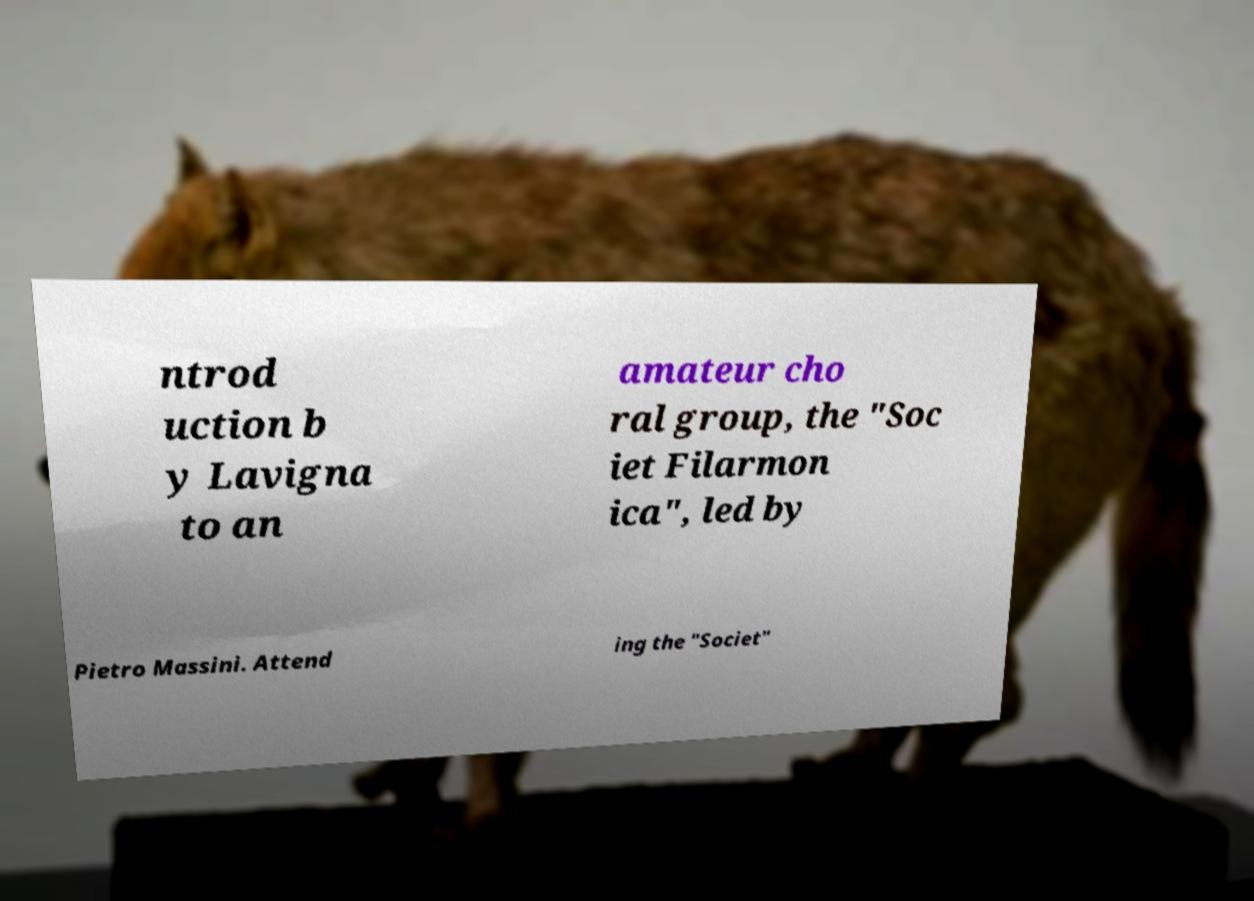I need the written content from this picture converted into text. Can you do that? ntrod uction b y Lavigna to an amateur cho ral group, the "Soc iet Filarmon ica", led by Pietro Massini. Attend ing the "Societ" 